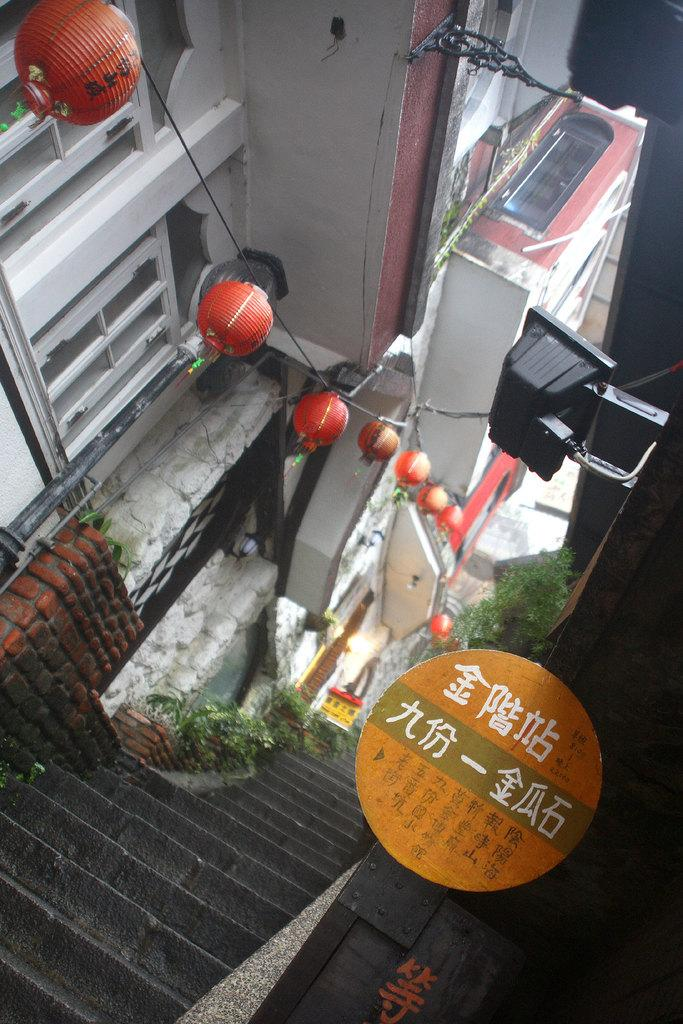What is the main object in the image? There is a board in the image. What color is the object on the board? There is a black object in the image. What architectural feature can be seen in the image? There are steps in the image. What type of vegetation is present near the steps? There are plants on the left side of the steps. What type of structures are visible in the background? There are buildings visible in the image. What is attached to the wire in the image? There is a wire with decorative items in the image. What type of quilt is draped over the end of the steps in the image? There is no quilt present in the image, and no mention of an end of the steps. 